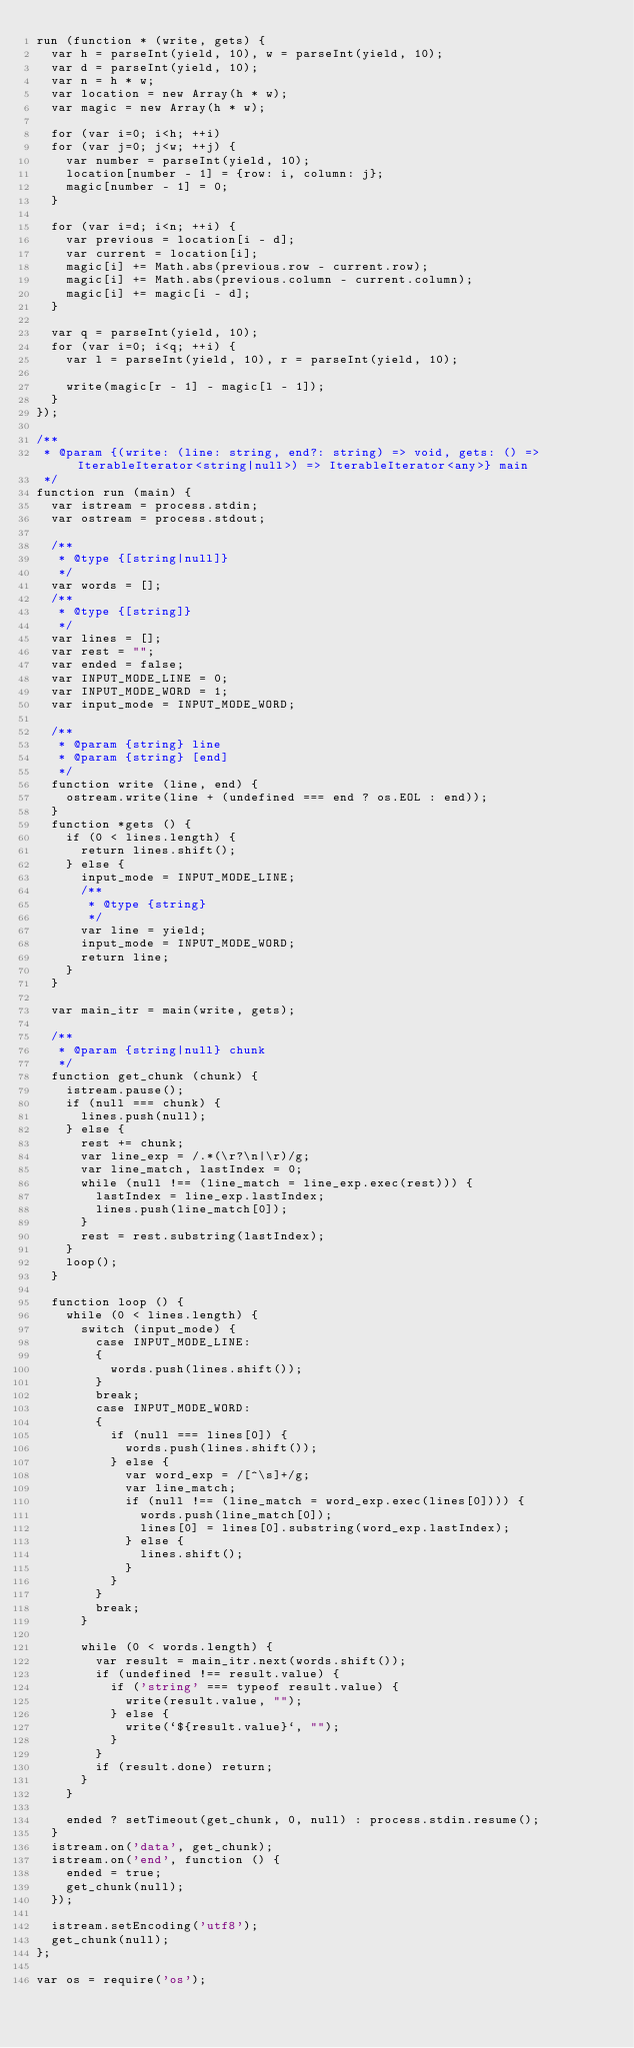Convert code to text. <code><loc_0><loc_0><loc_500><loc_500><_JavaScript_>run (function * (write, gets) {
	var h = parseInt(yield, 10), w = parseInt(yield, 10);
	var d = parseInt(yield, 10);
	var n = h * w;
	var location = new Array(h * w);
	var magic = new Array(h * w);

	for (var i=0; i<h; ++i)
	for (var j=0; j<w; ++j) {
		var number = parseInt(yield, 10);
		location[number - 1] = {row: i, column: j};
		magic[number - 1] = 0;
	}

	for (var i=d; i<n; ++i) {
		var previous = location[i - d];
		var current = location[i];
		magic[i] += Math.abs(previous.row - current.row);
		magic[i] += Math.abs(previous.column - current.column);
		magic[i] += magic[i - d];
	}

	var q = parseInt(yield, 10);
	for (var i=0; i<q; ++i) {
		var l = parseInt(yield, 10), r = parseInt(yield, 10);

		write(magic[r - 1] - magic[l - 1]);
	}
});

/**
 * @param {(write: (line: string, end?: string) => void, gets: () => IterableIterator<string|null>) => IterableIterator<any>} main 
 */
function run (main) {
	var istream = process.stdin;
	var ostream = process.stdout;

	/**
	 * @type {[string|null]}
	 */
	var words = [];
	/**
	 * @type {[string]}
	 */
	var lines = [];
	var rest = "";
	var ended = false;
	var INPUT_MODE_LINE = 0;
	var INPUT_MODE_WORD = 1;
	var input_mode = INPUT_MODE_WORD;

	/**
	 * @param {string} line 
	 * @param {string} [end] 
	 */
	function write (line, end) {
		ostream.write(line + (undefined === end ? os.EOL : end));
	}
	function *gets () {
		if (0 < lines.length) {
			return lines.shift();
		} else {
			input_mode = INPUT_MODE_LINE;
			/**
			 * @type {string}
			 */
			var line = yield;
			input_mode = INPUT_MODE_WORD;
			return line;
		}
	}

	var main_itr = main(write, gets);

	/**
	 * @param {string|null} chunk 
	 */
	function get_chunk (chunk) {
		istream.pause();
		if (null === chunk) {
			lines.push(null);
		} else {
			rest += chunk;
			var line_exp = /.*(\r?\n|\r)/g;
			var line_match, lastIndex = 0;
			while (null !== (line_match = line_exp.exec(rest))) {
				lastIndex = line_exp.lastIndex;
				lines.push(line_match[0]);
			}
			rest = rest.substring(lastIndex);
		}
		loop();
	}

	function loop () {
		while (0 < lines.length) {
			switch (input_mode) {
				case INPUT_MODE_LINE:
				{
					words.push(lines.shift());
				}
				break;
				case INPUT_MODE_WORD:
				{
					if (null === lines[0]) {
						words.push(lines.shift());
					} else {
						var word_exp = /[^\s]+/g;
						var line_match;
						if (null !== (line_match = word_exp.exec(lines[0]))) {
							words.push(line_match[0]);
							lines[0] = lines[0].substring(word_exp.lastIndex);
						} else {
							lines.shift();
						}
					}
				}
				break;
			}

			while (0 < words.length) {
				var result = main_itr.next(words.shift());
				if (undefined !== result.value) {
					if ('string' === typeof result.value) {
						write(result.value, "");
					} else {
						write(`${result.value}`, "");
					}
				}
				if (result.done) return;
			}
		}

		ended ? setTimeout(get_chunk, 0, null) : process.stdin.resume();
	}
	istream.on('data', get_chunk);
	istream.on('end', function () {
		ended = true;
		get_chunk(null);
	});

	istream.setEncoding('utf8');
	get_chunk(null);
};

var os = require('os');
</code> 